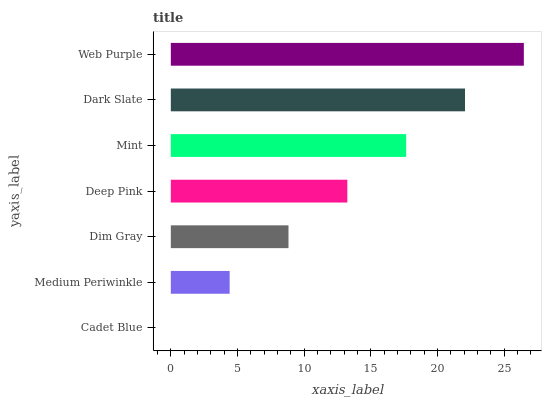Is Cadet Blue the minimum?
Answer yes or no. Yes. Is Web Purple the maximum?
Answer yes or no. Yes. Is Medium Periwinkle the minimum?
Answer yes or no. No. Is Medium Periwinkle the maximum?
Answer yes or no. No. Is Medium Periwinkle greater than Cadet Blue?
Answer yes or no. Yes. Is Cadet Blue less than Medium Periwinkle?
Answer yes or no. Yes. Is Cadet Blue greater than Medium Periwinkle?
Answer yes or no. No. Is Medium Periwinkle less than Cadet Blue?
Answer yes or no. No. Is Deep Pink the high median?
Answer yes or no. Yes. Is Deep Pink the low median?
Answer yes or no. Yes. Is Dark Slate the high median?
Answer yes or no. No. Is Dim Gray the low median?
Answer yes or no. No. 